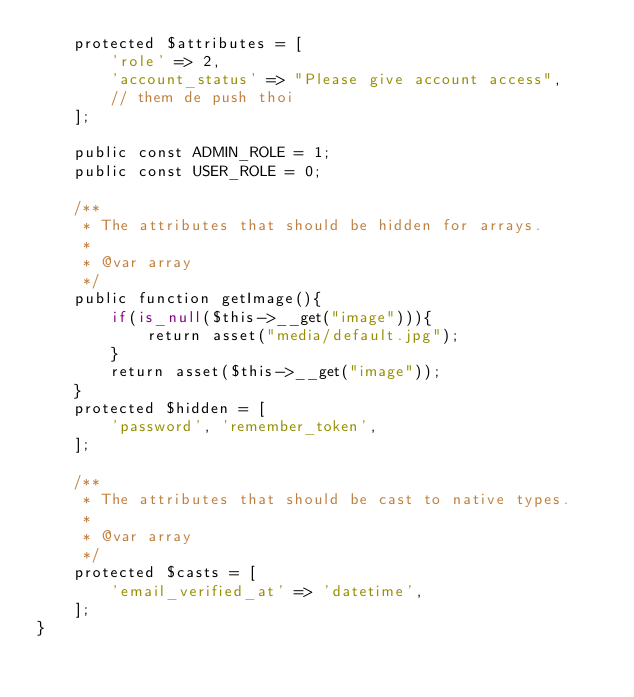Convert code to text. <code><loc_0><loc_0><loc_500><loc_500><_PHP_>    protected $attributes = [
        'role' => 2,
        'account_status' => "Please give account access",
        // them de push thoi
    ];

    public const ADMIN_ROLE = 1;
    public const USER_ROLE = 0;

    /**
     * The attributes that should be hidden for arrays.
     *
     * @var array
     */
    public function getImage(){
        if(is_null($this->__get("image"))){
            return asset("media/default.jpg");
        }
        return asset($this->__get("image"));
    }
    protected $hidden = [
        'password', 'remember_token',
    ];

    /**
     * The attributes that should be cast to native types.
     *
     * @var array
     */
    protected $casts = [
        'email_verified_at' => 'datetime',
    ];
}
</code> 